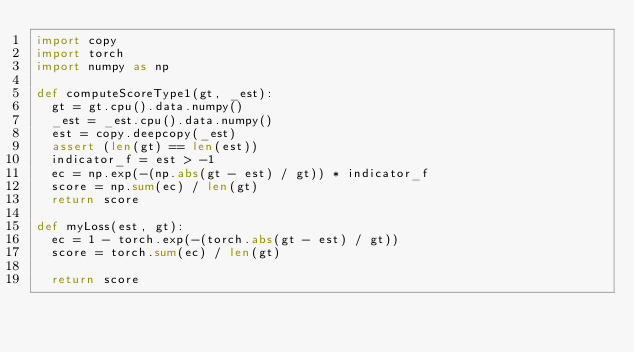Convert code to text. <code><loc_0><loc_0><loc_500><loc_500><_Python_>import copy
import torch
import numpy as np

def computeScoreType1(gt, _est):
  gt = gt.cpu().data.numpy()
  _est = _est.cpu().data.numpy()
  est = copy.deepcopy(_est)
  assert (len(gt) == len(est))
  indicator_f = est > -1
  ec = np.exp(-(np.abs(gt - est) / gt)) * indicator_f
  score = np.sum(ec) / len(gt)
  return score

def myLoss(est, gt):
  ec = 1 - torch.exp(-(torch.abs(gt - est) / gt))
  score = torch.sum(ec) / len(gt)

  return score

</code> 